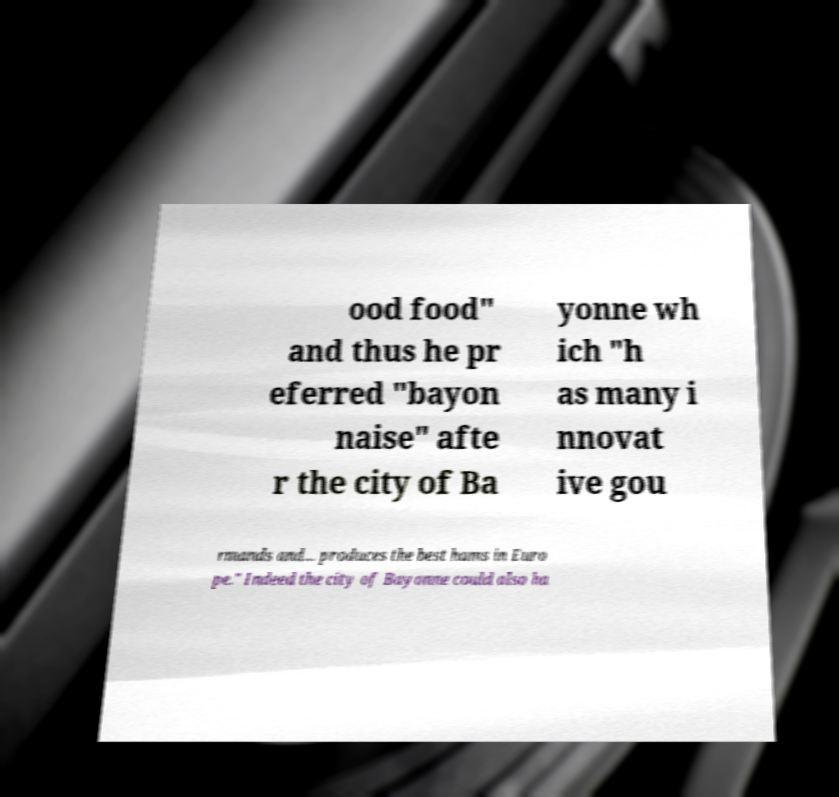There's text embedded in this image that I need extracted. Can you transcribe it verbatim? ood food" and thus he pr eferred "bayon naise" afte r the city of Ba yonne wh ich "h as many i nnovat ive gou rmands and... produces the best hams in Euro pe." Indeed the city of Bayonne could also ha 